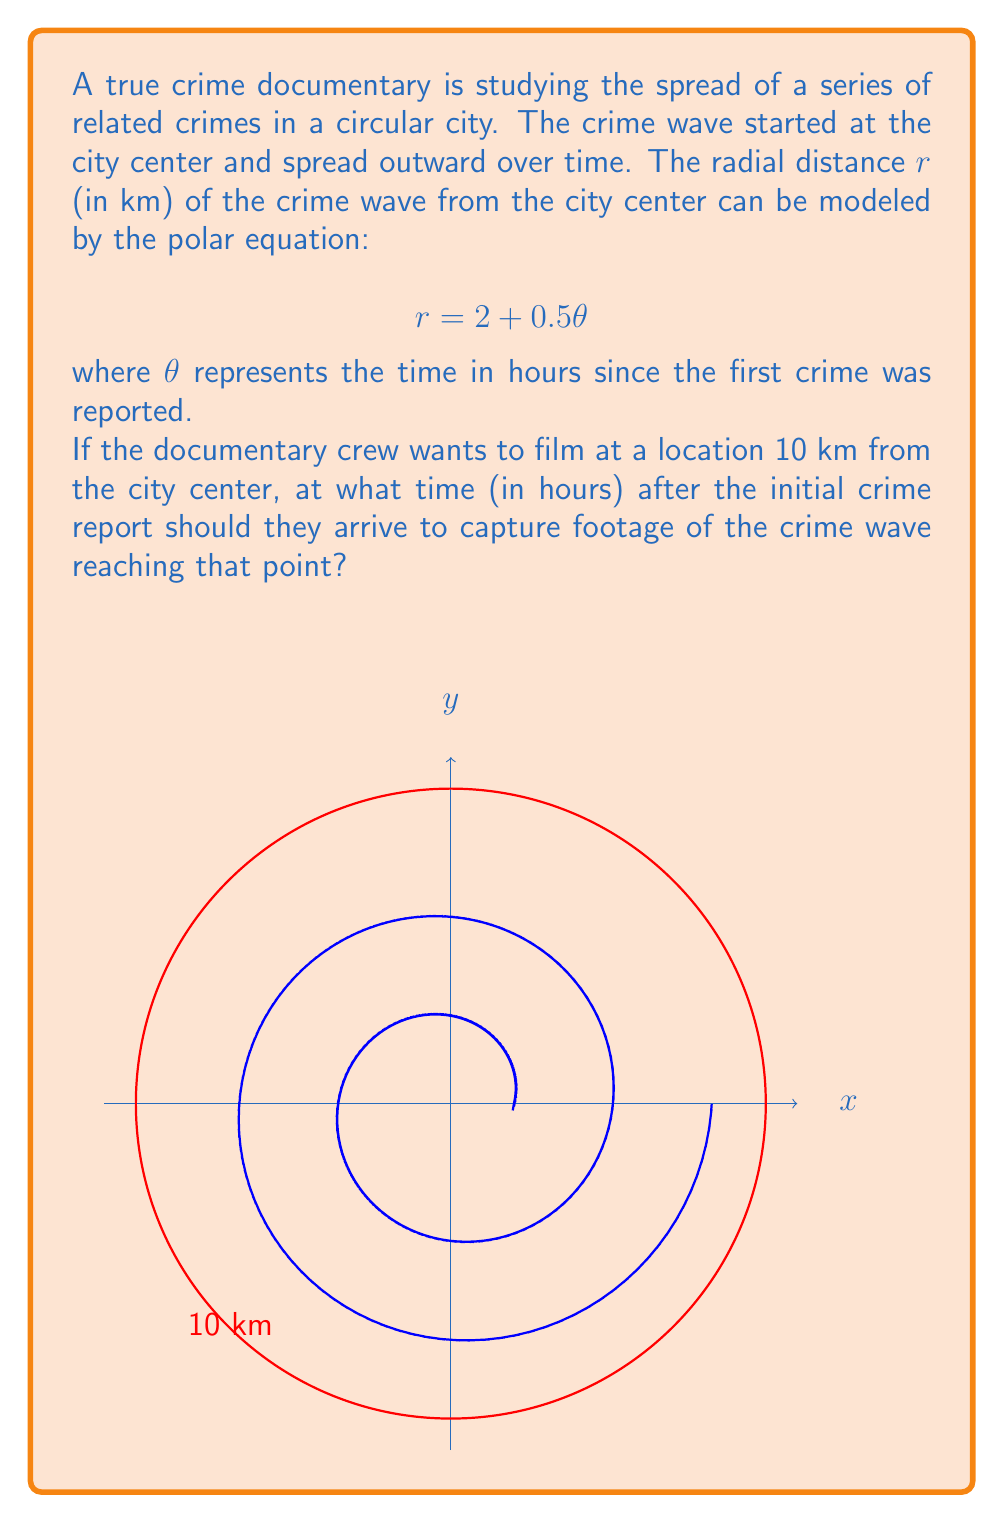Teach me how to tackle this problem. Let's approach this step-by-step:

1) We're given the polar equation $r = 2 + 0.5\theta$, where $r$ is the radial distance in km and $\theta$ is the time in hours.

2) We want to find the time when the crime wave reaches 10 km from the center. So, we need to solve the equation when $r = 10$.

3) Let's substitute $r = 10$ into our equation:

   $10 = 2 + 0.5\theta$

4) Now, let's solve for $\theta$:
   
   $10 - 2 = 0.5\theta$
   $8 = 0.5\theta$

5) Multiply both sides by 2:

   $16 = \theta$

6) Therefore, the crime wave will reach a distance of 10 km from the city center 16 hours after the initial crime report.

This solution aligns with the true crime documentary context, as it helps the crew determine the optimal time to film the progression of the crime wave, emphasizing the importance of timing in capturing such events.
Answer: 16 hours 